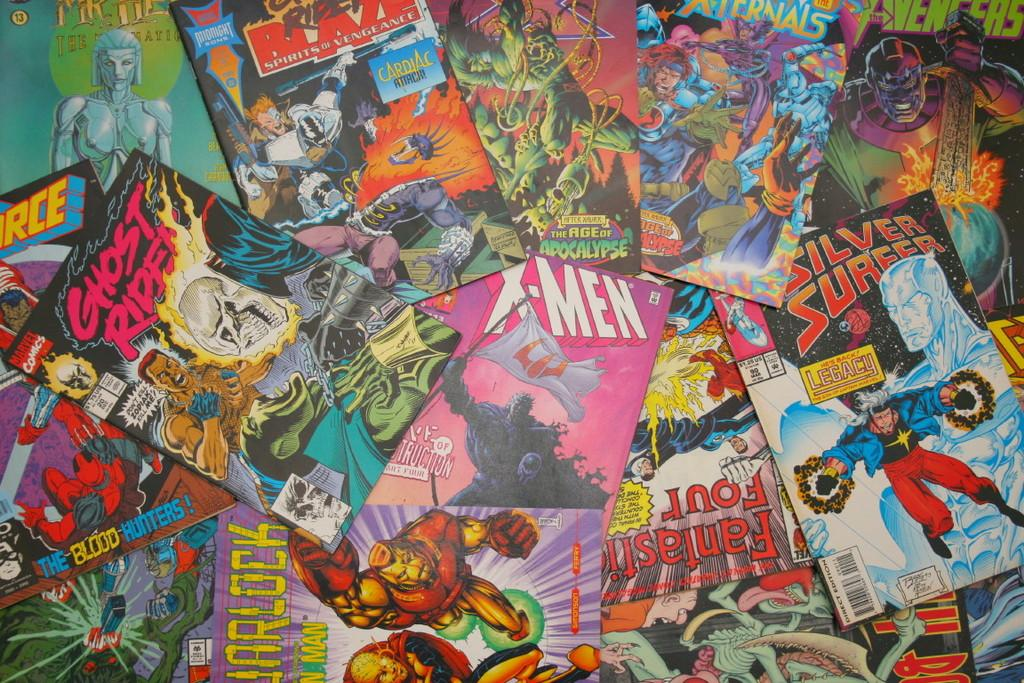What type of reading material is present in the image? There are comic books in the image. What color is the sock on the character's foot in the comic book? There is no sock or character's foot visible in the image, as it only features comic books. 